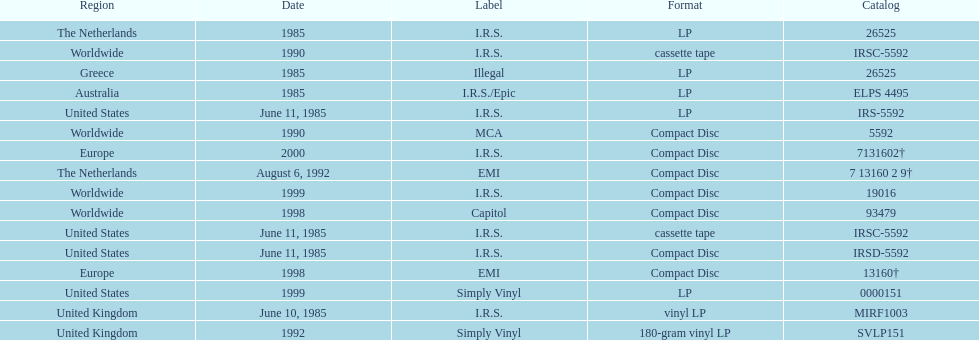How many times was the album released? 13. 